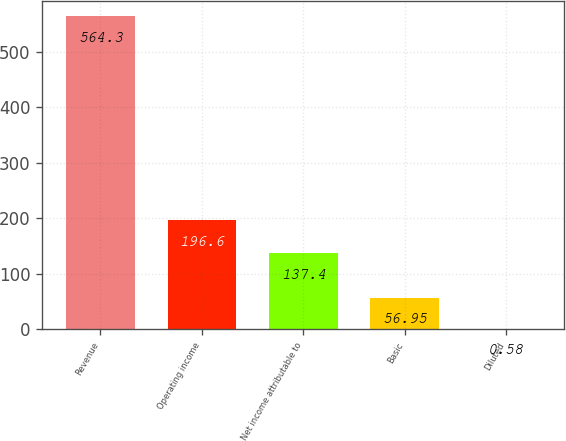Convert chart. <chart><loc_0><loc_0><loc_500><loc_500><bar_chart><fcel>Revenue<fcel>Operating income<fcel>Net income attributable to<fcel>Basic<fcel>Diluted<nl><fcel>564.3<fcel>196.6<fcel>137.4<fcel>56.95<fcel>0.58<nl></chart> 